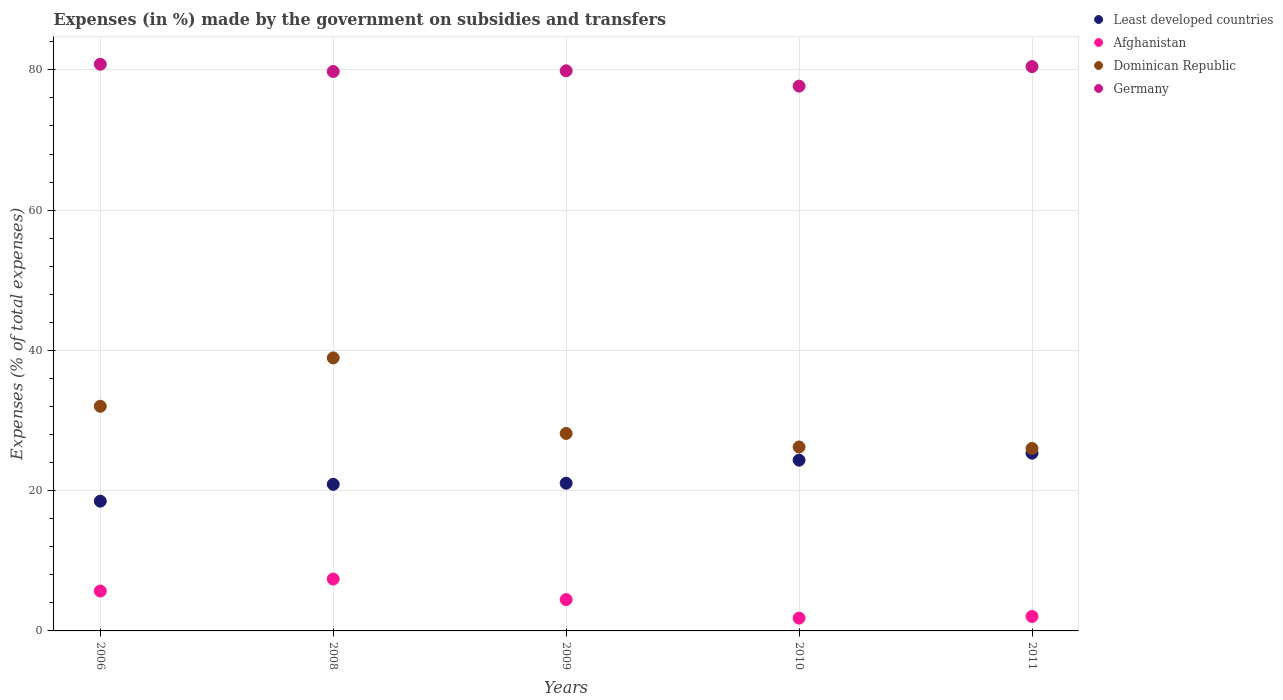How many different coloured dotlines are there?
Make the answer very short. 4. What is the percentage of expenses made by the government on subsidies and transfers in Least developed countries in 2009?
Give a very brief answer. 21.06. Across all years, what is the maximum percentage of expenses made by the government on subsidies and transfers in Dominican Republic?
Your answer should be very brief. 38.93. Across all years, what is the minimum percentage of expenses made by the government on subsidies and transfers in Afghanistan?
Keep it short and to the point. 1.82. In which year was the percentage of expenses made by the government on subsidies and transfers in Dominican Republic maximum?
Offer a terse response. 2008. In which year was the percentage of expenses made by the government on subsidies and transfers in Least developed countries minimum?
Your response must be concise. 2006. What is the total percentage of expenses made by the government on subsidies and transfers in Germany in the graph?
Your response must be concise. 398.6. What is the difference between the percentage of expenses made by the government on subsidies and transfers in Least developed countries in 2010 and that in 2011?
Offer a terse response. -1. What is the difference between the percentage of expenses made by the government on subsidies and transfers in Dominican Republic in 2006 and the percentage of expenses made by the government on subsidies and transfers in Afghanistan in 2011?
Your response must be concise. 29.97. What is the average percentage of expenses made by the government on subsidies and transfers in Afghanistan per year?
Provide a succinct answer. 4.29. In the year 2009, what is the difference between the percentage of expenses made by the government on subsidies and transfers in Germany and percentage of expenses made by the government on subsidies and transfers in Dominican Republic?
Your answer should be very brief. 51.71. What is the ratio of the percentage of expenses made by the government on subsidies and transfers in Germany in 2009 to that in 2010?
Your response must be concise. 1.03. Is the percentage of expenses made by the government on subsidies and transfers in Least developed countries in 2009 less than that in 2010?
Your answer should be compact. Yes. What is the difference between the highest and the second highest percentage of expenses made by the government on subsidies and transfers in Least developed countries?
Ensure brevity in your answer.  1. What is the difference between the highest and the lowest percentage of expenses made by the government on subsidies and transfers in Least developed countries?
Make the answer very short. 6.84. In how many years, is the percentage of expenses made by the government on subsidies and transfers in Germany greater than the average percentage of expenses made by the government on subsidies and transfers in Germany taken over all years?
Offer a very short reply. 4. Is it the case that in every year, the sum of the percentage of expenses made by the government on subsidies and transfers in Germany and percentage of expenses made by the government on subsidies and transfers in Least developed countries  is greater than the sum of percentage of expenses made by the government on subsidies and transfers in Dominican Republic and percentage of expenses made by the government on subsidies and transfers in Afghanistan?
Offer a terse response. Yes. Does the percentage of expenses made by the government on subsidies and transfers in Afghanistan monotonically increase over the years?
Your answer should be compact. No. Is the percentage of expenses made by the government on subsidies and transfers in Dominican Republic strictly greater than the percentage of expenses made by the government on subsidies and transfers in Least developed countries over the years?
Provide a short and direct response. Yes. Is the percentage of expenses made by the government on subsidies and transfers in Germany strictly less than the percentage of expenses made by the government on subsidies and transfers in Dominican Republic over the years?
Your answer should be compact. No. What is the difference between two consecutive major ticks on the Y-axis?
Your answer should be compact. 20. Does the graph contain any zero values?
Give a very brief answer. No. Does the graph contain grids?
Keep it short and to the point. Yes. How are the legend labels stacked?
Give a very brief answer. Vertical. What is the title of the graph?
Offer a very short reply. Expenses (in %) made by the government on subsidies and transfers. Does "Congo (Democratic)" appear as one of the legend labels in the graph?
Your answer should be compact. No. What is the label or title of the Y-axis?
Provide a short and direct response. Expenses (% of total expenses). What is the Expenses (% of total expenses) of Least developed countries in 2006?
Ensure brevity in your answer.  18.5. What is the Expenses (% of total expenses) in Afghanistan in 2006?
Provide a short and direct response. 5.69. What is the Expenses (% of total expenses) of Dominican Republic in 2006?
Give a very brief answer. 32.03. What is the Expenses (% of total expenses) of Germany in 2006?
Provide a short and direct response. 80.8. What is the Expenses (% of total expenses) in Least developed countries in 2008?
Offer a terse response. 20.9. What is the Expenses (% of total expenses) of Afghanistan in 2008?
Make the answer very short. 7.4. What is the Expenses (% of total expenses) in Dominican Republic in 2008?
Keep it short and to the point. 38.93. What is the Expenses (% of total expenses) in Germany in 2008?
Your answer should be compact. 79.77. What is the Expenses (% of total expenses) in Least developed countries in 2009?
Provide a short and direct response. 21.06. What is the Expenses (% of total expenses) of Afghanistan in 2009?
Provide a short and direct response. 4.47. What is the Expenses (% of total expenses) of Dominican Republic in 2009?
Offer a very short reply. 28.16. What is the Expenses (% of total expenses) of Germany in 2009?
Keep it short and to the point. 79.87. What is the Expenses (% of total expenses) of Least developed countries in 2010?
Offer a terse response. 24.35. What is the Expenses (% of total expenses) of Afghanistan in 2010?
Your answer should be compact. 1.82. What is the Expenses (% of total expenses) in Dominican Republic in 2010?
Provide a succinct answer. 26.23. What is the Expenses (% of total expenses) of Germany in 2010?
Your answer should be compact. 77.69. What is the Expenses (% of total expenses) in Least developed countries in 2011?
Keep it short and to the point. 25.34. What is the Expenses (% of total expenses) in Afghanistan in 2011?
Your response must be concise. 2.06. What is the Expenses (% of total expenses) of Dominican Republic in 2011?
Make the answer very short. 26.02. What is the Expenses (% of total expenses) of Germany in 2011?
Offer a terse response. 80.47. Across all years, what is the maximum Expenses (% of total expenses) in Least developed countries?
Offer a terse response. 25.34. Across all years, what is the maximum Expenses (% of total expenses) of Afghanistan?
Provide a succinct answer. 7.4. Across all years, what is the maximum Expenses (% of total expenses) in Dominican Republic?
Ensure brevity in your answer.  38.93. Across all years, what is the maximum Expenses (% of total expenses) of Germany?
Make the answer very short. 80.8. Across all years, what is the minimum Expenses (% of total expenses) in Least developed countries?
Provide a short and direct response. 18.5. Across all years, what is the minimum Expenses (% of total expenses) of Afghanistan?
Your answer should be very brief. 1.82. Across all years, what is the minimum Expenses (% of total expenses) of Dominican Republic?
Ensure brevity in your answer.  26.02. Across all years, what is the minimum Expenses (% of total expenses) of Germany?
Your response must be concise. 77.69. What is the total Expenses (% of total expenses) of Least developed countries in the graph?
Give a very brief answer. 110.16. What is the total Expenses (% of total expenses) in Afghanistan in the graph?
Offer a very short reply. 21.44. What is the total Expenses (% of total expenses) of Dominican Republic in the graph?
Your answer should be compact. 151.37. What is the total Expenses (% of total expenses) of Germany in the graph?
Offer a very short reply. 398.6. What is the difference between the Expenses (% of total expenses) in Least developed countries in 2006 and that in 2008?
Your response must be concise. -2.4. What is the difference between the Expenses (% of total expenses) of Afghanistan in 2006 and that in 2008?
Ensure brevity in your answer.  -1.71. What is the difference between the Expenses (% of total expenses) in Dominican Republic in 2006 and that in 2008?
Offer a terse response. -6.9. What is the difference between the Expenses (% of total expenses) of Germany in 2006 and that in 2008?
Offer a very short reply. 1.03. What is the difference between the Expenses (% of total expenses) of Least developed countries in 2006 and that in 2009?
Offer a very short reply. -2.56. What is the difference between the Expenses (% of total expenses) of Afghanistan in 2006 and that in 2009?
Make the answer very short. 1.22. What is the difference between the Expenses (% of total expenses) of Dominican Republic in 2006 and that in 2009?
Your answer should be compact. 3.88. What is the difference between the Expenses (% of total expenses) of Germany in 2006 and that in 2009?
Ensure brevity in your answer.  0.93. What is the difference between the Expenses (% of total expenses) in Least developed countries in 2006 and that in 2010?
Provide a short and direct response. -5.85. What is the difference between the Expenses (% of total expenses) of Afghanistan in 2006 and that in 2010?
Offer a very short reply. 3.86. What is the difference between the Expenses (% of total expenses) of Dominican Republic in 2006 and that in 2010?
Your answer should be very brief. 5.8. What is the difference between the Expenses (% of total expenses) in Germany in 2006 and that in 2010?
Provide a short and direct response. 3.11. What is the difference between the Expenses (% of total expenses) of Least developed countries in 2006 and that in 2011?
Give a very brief answer. -6.84. What is the difference between the Expenses (% of total expenses) in Afghanistan in 2006 and that in 2011?
Keep it short and to the point. 3.63. What is the difference between the Expenses (% of total expenses) of Dominican Republic in 2006 and that in 2011?
Your answer should be very brief. 6.02. What is the difference between the Expenses (% of total expenses) in Germany in 2006 and that in 2011?
Your response must be concise. 0.33. What is the difference between the Expenses (% of total expenses) of Least developed countries in 2008 and that in 2009?
Keep it short and to the point. -0.16. What is the difference between the Expenses (% of total expenses) in Afghanistan in 2008 and that in 2009?
Keep it short and to the point. 2.93. What is the difference between the Expenses (% of total expenses) of Dominican Republic in 2008 and that in 2009?
Provide a short and direct response. 10.78. What is the difference between the Expenses (% of total expenses) of Germany in 2008 and that in 2009?
Your answer should be compact. -0.1. What is the difference between the Expenses (% of total expenses) in Least developed countries in 2008 and that in 2010?
Your response must be concise. -3.45. What is the difference between the Expenses (% of total expenses) in Afghanistan in 2008 and that in 2010?
Ensure brevity in your answer.  5.57. What is the difference between the Expenses (% of total expenses) in Dominican Republic in 2008 and that in 2010?
Your answer should be very brief. 12.7. What is the difference between the Expenses (% of total expenses) in Germany in 2008 and that in 2010?
Your response must be concise. 2.08. What is the difference between the Expenses (% of total expenses) in Least developed countries in 2008 and that in 2011?
Provide a succinct answer. -4.44. What is the difference between the Expenses (% of total expenses) of Afghanistan in 2008 and that in 2011?
Ensure brevity in your answer.  5.34. What is the difference between the Expenses (% of total expenses) of Dominican Republic in 2008 and that in 2011?
Make the answer very short. 12.92. What is the difference between the Expenses (% of total expenses) of Germany in 2008 and that in 2011?
Make the answer very short. -0.7. What is the difference between the Expenses (% of total expenses) in Least developed countries in 2009 and that in 2010?
Ensure brevity in your answer.  -3.29. What is the difference between the Expenses (% of total expenses) in Afghanistan in 2009 and that in 2010?
Your response must be concise. 2.64. What is the difference between the Expenses (% of total expenses) in Dominican Republic in 2009 and that in 2010?
Provide a succinct answer. 1.93. What is the difference between the Expenses (% of total expenses) in Germany in 2009 and that in 2010?
Keep it short and to the point. 2.18. What is the difference between the Expenses (% of total expenses) in Least developed countries in 2009 and that in 2011?
Ensure brevity in your answer.  -4.28. What is the difference between the Expenses (% of total expenses) of Afghanistan in 2009 and that in 2011?
Give a very brief answer. 2.4. What is the difference between the Expenses (% of total expenses) in Dominican Republic in 2009 and that in 2011?
Offer a very short reply. 2.14. What is the difference between the Expenses (% of total expenses) of Germany in 2009 and that in 2011?
Provide a succinct answer. -0.6. What is the difference between the Expenses (% of total expenses) in Least developed countries in 2010 and that in 2011?
Ensure brevity in your answer.  -1. What is the difference between the Expenses (% of total expenses) of Afghanistan in 2010 and that in 2011?
Provide a short and direct response. -0.24. What is the difference between the Expenses (% of total expenses) of Dominican Republic in 2010 and that in 2011?
Make the answer very short. 0.21. What is the difference between the Expenses (% of total expenses) of Germany in 2010 and that in 2011?
Provide a short and direct response. -2.78. What is the difference between the Expenses (% of total expenses) of Least developed countries in 2006 and the Expenses (% of total expenses) of Afghanistan in 2008?
Make the answer very short. 11.1. What is the difference between the Expenses (% of total expenses) in Least developed countries in 2006 and the Expenses (% of total expenses) in Dominican Republic in 2008?
Provide a succinct answer. -20.43. What is the difference between the Expenses (% of total expenses) in Least developed countries in 2006 and the Expenses (% of total expenses) in Germany in 2008?
Your answer should be very brief. -61.27. What is the difference between the Expenses (% of total expenses) in Afghanistan in 2006 and the Expenses (% of total expenses) in Dominican Republic in 2008?
Provide a short and direct response. -33.25. What is the difference between the Expenses (% of total expenses) in Afghanistan in 2006 and the Expenses (% of total expenses) in Germany in 2008?
Provide a succinct answer. -74.08. What is the difference between the Expenses (% of total expenses) in Dominican Republic in 2006 and the Expenses (% of total expenses) in Germany in 2008?
Keep it short and to the point. -47.74. What is the difference between the Expenses (% of total expenses) in Least developed countries in 2006 and the Expenses (% of total expenses) in Afghanistan in 2009?
Your answer should be compact. 14.04. What is the difference between the Expenses (% of total expenses) of Least developed countries in 2006 and the Expenses (% of total expenses) of Dominican Republic in 2009?
Offer a very short reply. -9.65. What is the difference between the Expenses (% of total expenses) of Least developed countries in 2006 and the Expenses (% of total expenses) of Germany in 2009?
Give a very brief answer. -61.37. What is the difference between the Expenses (% of total expenses) in Afghanistan in 2006 and the Expenses (% of total expenses) in Dominican Republic in 2009?
Make the answer very short. -22.47. What is the difference between the Expenses (% of total expenses) of Afghanistan in 2006 and the Expenses (% of total expenses) of Germany in 2009?
Your response must be concise. -74.18. What is the difference between the Expenses (% of total expenses) in Dominican Republic in 2006 and the Expenses (% of total expenses) in Germany in 2009?
Ensure brevity in your answer.  -47.84. What is the difference between the Expenses (% of total expenses) in Least developed countries in 2006 and the Expenses (% of total expenses) in Afghanistan in 2010?
Offer a very short reply. 16.68. What is the difference between the Expenses (% of total expenses) of Least developed countries in 2006 and the Expenses (% of total expenses) of Dominican Republic in 2010?
Give a very brief answer. -7.73. What is the difference between the Expenses (% of total expenses) in Least developed countries in 2006 and the Expenses (% of total expenses) in Germany in 2010?
Give a very brief answer. -59.18. What is the difference between the Expenses (% of total expenses) in Afghanistan in 2006 and the Expenses (% of total expenses) in Dominican Republic in 2010?
Provide a short and direct response. -20.54. What is the difference between the Expenses (% of total expenses) in Afghanistan in 2006 and the Expenses (% of total expenses) in Germany in 2010?
Provide a succinct answer. -72. What is the difference between the Expenses (% of total expenses) of Dominican Republic in 2006 and the Expenses (% of total expenses) of Germany in 2010?
Give a very brief answer. -45.66. What is the difference between the Expenses (% of total expenses) of Least developed countries in 2006 and the Expenses (% of total expenses) of Afghanistan in 2011?
Give a very brief answer. 16.44. What is the difference between the Expenses (% of total expenses) of Least developed countries in 2006 and the Expenses (% of total expenses) of Dominican Republic in 2011?
Your answer should be very brief. -7.51. What is the difference between the Expenses (% of total expenses) in Least developed countries in 2006 and the Expenses (% of total expenses) in Germany in 2011?
Give a very brief answer. -61.97. What is the difference between the Expenses (% of total expenses) of Afghanistan in 2006 and the Expenses (% of total expenses) of Dominican Republic in 2011?
Provide a short and direct response. -20.33. What is the difference between the Expenses (% of total expenses) in Afghanistan in 2006 and the Expenses (% of total expenses) in Germany in 2011?
Provide a short and direct response. -74.78. What is the difference between the Expenses (% of total expenses) of Dominican Republic in 2006 and the Expenses (% of total expenses) of Germany in 2011?
Provide a short and direct response. -48.44. What is the difference between the Expenses (% of total expenses) in Least developed countries in 2008 and the Expenses (% of total expenses) in Afghanistan in 2009?
Your answer should be compact. 16.44. What is the difference between the Expenses (% of total expenses) in Least developed countries in 2008 and the Expenses (% of total expenses) in Dominican Republic in 2009?
Ensure brevity in your answer.  -7.25. What is the difference between the Expenses (% of total expenses) in Least developed countries in 2008 and the Expenses (% of total expenses) in Germany in 2009?
Your answer should be compact. -58.97. What is the difference between the Expenses (% of total expenses) of Afghanistan in 2008 and the Expenses (% of total expenses) of Dominican Republic in 2009?
Provide a succinct answer. -20.76. What is the difference between the Expenses (% of total expenses) of Afghanistan in 2008 and the Expenses (% of total expenses) of Germany in 2009?
Provide a short and direct response. -72.47. What is the difference between the Expenses (% of total expenses) of Dominican Republic in 2008 and the Expenses (% of total expenses) of Germany in 2009?
Make the answer very short. -40.94. What is the difference between the Expenses (% of total expenses) of Least developed countries in 2008 and the Expenses (% of total expenses) of Afghanistan in 2010?
Offer a very short reply. 19.08. What is the difference between the Expenses (% of total expenses) in Least developed countries in 2008 and the Expenses (% of total expenses) in Dominican Republic in 2010?
Provide a succinct answer. -5.33. What is the difference between the Expenses (% of total expenses) of Least developed countries in 2008 and the Expenses (% of total expenses) of Germany in 2010?
Your answer should be compact. -56.78. What is the difference between the Expenses (% of total expenses) of Afghanistan in 2008 and the Expenses (% of total expenses) of Dominican Republic in 2010?
Your response must be concise. -18.83. What is the difference between the Expenses (% of total expenses) in Afghanistan in 2008 and the Expenses (% of total expenses) in Germany in 2010?
Your answer should be very brief. -70.29. What is the difference between the Expenses (% of total expenses) in Dominican Republic in 2008 and the Expenses (% of total expenses) in Germany in 2010?
Your answer should be compact. -38.75. What is the difference between the Expenses (% of total expenses) of Least developed countries in 2008 and the Expenses (% of total expenses) of Afghanistan in 2011?
Provide a short and direct response. 18.84. What is the difference between the Expenses (% of total expenses) in Least developed countries in 2008 and the Expenses (% of total expenses) in Dominican Republic in 2011?
Your answer should be compact. -5.11. What is the difference between the Expenses (% of total expenses) in Least developed countries in 2008 and the Expenses (% of total expenses) in Germany in 2011?
Provide a succinct answer. -59.57. What is the difference between the Expenses (% of total expenses) in Afghanistan in 2008 and the Expenses (% of total expenses) in Dominican Republic in 2011?
Make the answer very short. -18.62. What is the difference between the Expenses (% of total expenses) in Afghanistan in 2008 and the Expenses (% of total expenses) in Germany in 2011?
Keep it short and to the point. -73.07. What is the difference between the Expenses (% of total expenses) in Dominican Republic in 2008 and the Expenses (% of total expenses) in Germany in 2011?
Give a very brief answer. -41.54. What is the difference between the Expenses (% of total expenses) in Least developed countries in 2009 and the Expenses (% of total expenses) in Afghanistan in 2010?
Offer a very short reply. 19.24. What is the difference between the Expenses (% of total expenses) in Least developed countries in 2009 and the Expenses (% of total expenses) in Dominican Republic in 2010?
Keep it short and to the point. -5.17. What is the difference between the Expenses (% of total expenses) of Least developed countries in 2009 and the Expenses (% of total expenses) of Germany in 2010?
Offer a very short reply. -56.62. What is the difference between the Expenses (% of total expenses) of Afghanistan in 2009 and the Expenses (% of total expenses) of Dominican Republic in 2010?
Your response must be concise. -21.76. What is the difference between the Expenses (% of total expenses) of Afghanistan in 2009 and the Expenses (% of total expenses) of Germany in 2010?
Offer a terse response. -73.22. What is the difference between the Expenses (% of total expenses) of Dominican Republic in 2009 and the Expenses (% of total expenses) of Germany in 2010?
Offer a very short reply. -49.53. What is the difference between the Expenses (% of total expenses) in Least developed countries in 2009 and the Expenses (% of total expenses) in Afghanistan in 2011?
Ensure brevity in your answer.  19. What is the difference between the Expenses (% of total expenses) in Least developed countries in 2009 and the Expenses (% of total expenses) in Dominican Republic in 2011?
Offer a very short reply. -4.95. What is the difference between the Expenses (% of total expenses) in Least developed countries in 2009 and the Expenses (% of total expenses) in Germany in 2011?
Provide a short and direct response. -59.41. What is the difference between the Expenses (% of total expenses) in Afghanistan in 2009 and the Expenses (% of total expenses) in Dominican Republic in 2011?
Make the answer very short. -21.55. What is the difference between the Expenses (% of total expenses) of Afghanistan in 2009 and the Expenses (% of total expenses) of Germany in 2011?
Your answer should be very brief. -76. What is the difference between the Expenses (% of total expenses) of Dominican Republic in 2009 and the Expenses (% of total expenses) of Germany in 2011?
Your response must be concise. -52.31. What is the difference between the Expenses (% of total expenses) in Least developed countries in 2010 and the Expenses (% of total expenses) in Afghanistan in 2011?
Offer a very short reply. 22.29. What is the difference between the Expenses (% of total expenses) in Least developed countries in 2010 and the Expenses (% of total expenses) in Dominican Republic in 2011?
Keep it short and to the point. -1.67. What is the difference between the Expenses (% of total expenses) of Least developed countries in 2010 and the Expenses (% of total expenses) of Germany in 2011?
Your response must be concise. -56.12. What is the difference between the Expenses (% of total expenses) of Afghanistan in 2010 and the Expenses (% of total expenses) of Dominican Republic in 2011?
Keep it short and to the point. -24.19. What is the difference between the Expenses (% of total expenses) of Afghanistan in 2010 and the Expenses (% of total expenses) of Germany in 2011?
Offer a terse response. -78.65. What is the difference between the Expenses (% of total expenses) of Dominican Republic in 2010 and the Expenses (% of total expenses) of Germany in 2011?
Your answer should be compact. -54.24. What is the average Expenses (% of total expenses) in Least developed countries per year?
Give a very brief answer. 22.03. What is the average Expenses (% of total expenses) in Afghanistan per year?
Offer a very short reply. 4.29. What is the average Expenses (% of total expenses) of Dominican Republic per year?
Make the answer very short. 30.27. What is the average Expenses (% of total expenses) in Germany per year?
Make the answer very short. 79.72. In the year 2006, what is the difference between the Expenses (% of total expenses) in Least developed countries and Expenses (% of total expenses) in Afghanistan?
Provide a short and direct response. 12.81. In the year 2006, what is the difference between the Expenses (% of total expenses) of Least developed countries and Expenses (% of total expenses) of Dominican Republic?
Give a very brief answer. -13.53. In the year 2006, what is the difference between the Expenses (% of total expenses) in Least developed countries and Expenses (% of total expenses) in Germany?
Provide a succinct answer. -62.3. In the year 2006, what is the difference between the Expenses (% of total expenses) in Afghanistan and Expenses (% of total expenses) in Dominican Republic?
Your answer should be very brief. -26.34. In the year 2006, what is the difference between the Expenses (% of total expenses) of Afghanistan and Expenses (% of total expenses) of Germany?
Your response must be concise. -75.11. In the year 2006, what is the difference between the Expenses (% of total expenses) in Dominican Republic and Expenses (% of total expenses) in Germany?
Keep it short and to the point. -48.77. In the year 2008, what is the difference between the Expenses (% of total expenses) in Least developed countries and Expenses (% of total expenses) in Afghanistan?
Your response must be concise. 13.5. In the year 2008, what is the difference between the Expenses (% of total expenses) in Least developed countries and Expenses (% of total expenses) in Dominican Republic?
Provide a succinct answer. -18.03. In the year 2008, what is the difference between the Expenses (% of total expenses) in Least developed countries and Expenses (% of total expenses) in Germany?
Give a very brief answer. -58.87. In the year 2008, what is the difference between the Expenses (% of total expenses) in Afghanistan and Expenses (% of total expenses) in Dominican Republic?
Provide a short and direct response. -31.54. In the year 2008, what is the difference between the Expenses (% of total expenses) of Afghanistan and Expenses (% of total expenses) of Germany?
Offer a terse response. -72.37. In the year 2008, what is the difference between the Expenses (% of total expenses) of Dominican Republic and Expenses (% of total expenses) of Germany?
Your answer should be compact. -40.84. In the year 2009, what is the difference between the Expenses (% of total expenses) in Least developed countries and Expenses (% of total expenses) in Afghanistan?
Give a very brief answer. 16.6. In the year 2009, what is the difference between the Expenses (% of total expenses) of Least developed countries and Expenses (% of total expenses) of Dominican Republic?
Provide a succinct answer. -7.09. In the year 2009, what is the difference between the Expenses (% of total expenses) in Least developed countries and Expenses (% of total expenses) in Germany?
Your answer should be compact. -58.81. In the year 2009, what is the difference between the Expenses (% of total expenses) of Afghanistan and Expenses (% of total expenses) of Dominican Republic?
Your answer should be compact. -23.69. In the year 2009, what is the difference between the Expenses (% of total expenses) in Afghanistan and Expenses (% of total expenses) in Germany?
Provide a short and direct response. -75.4. In the year 2009, what is the difference between the Expenses (% of total expenses) of Dominican Republic and Expenses (% of total expenses) of Germany?
Keep it short and to the point. -51.71. In the year 2010, what is the difference between the Expenses (% of total expenses) in Least developed countries and Expenses (% of total expenses) in Afghanistan?
Your response must be concise. 22.52. In the year 2010, what is the difference between the Expenses (% of total expenses) in Least developed countries and Expenses (% of total expenses) in Dominican Republic?
Your answer should be very brief. -1.88. In the year 2010, what is the difference between the Expenses (% of total expenses) in Least developed countries and Expenses (% of total expenses) in Germany?
Give a very brief answer. -53.34. In the year 2010, what is the difference between the Expenses (% of total expenses) of Afghanistan and Expenses (% of total expenses) of Dominican Republic?
Your answer should be very brief. -24.4. In the year 2010, what is the difference between the Expenses (% of total expenses) of Afghanistan and Expenses (% of total expenses) of Germany?
Provide a short and direct response. -75.86. In the year 2010, what is the difference between the Expenses (% of total expenses) of Dominican Republic and Expenses (% of total expenses) of Germany?
Give a very brief answer. -51.46. In the year 2011, what is the difference between the Expenses (% of total expenses) in Least developed countries and Expenses (% of total expenses) in Afghanistan?
Offer a very short reply. 23.28. In the year 2011, what is the difference between the Expenses (% of total expenses) in Least developed countries and Expenses (% of total expenses) in Dominican Republic?
Make the answer very short. -0.67. In the year 2011, what is the difference between the Expenses (% of total expenses) of Least developed countries and Expenses (% of total expenses) of Germany?
Offer a terse response. -55.13. In the year 2011, what is the difference between the Expenses (% of total expenses) in Afghanistan and Expenses (% of total expenses) in Dominican Republic?
Provide a succinct answer. -23.95. In the year 2011, what is the difference between the Expenses (% of total expenses) of Afghanistan and Expenses (% of total expenses) of Germany?
Provide a short and direct response. -78.41. In the year 2011, what is the difference between the Expenses (% of total expenses) of Dominican Republic and Expenses (% of total expenses) of Germany?
Ensure brevity in your answer.  -54.45. What is the ratio of the Expenses (% of total expenses) of Least developed countries in 2006 to that in 2008?
Give a very brief answer. 0.89. What is the ratio of the Expenses (% of total expenses) in Afghanistan in 2006 to that in 2008?
Your response must be concise. 0.77. What is the ratio of the Expenses (% of total expenses) in Dominican Republic in 2006 to that in 2008?
Offer a terse response. 0.82. What is the ratio of the Expenses (% of total expenses) of Germany in 2006 to that in 2008?
Give a very brief answer. 1.01. What is the ratio of the Expenses (% of total expenses) in Least developed countries in 2006 to that in 2009?
Provide a succinct answer. 0.88. What is the ratio of the Expenses (% of total expenses) in Afghanistan in 2006 to that in 2009?
Provide a succinct answer. 1.27. What is the ratio of the Expenses (% of total expenses) of Dominican Republic in 2006 to that in 2009?
Give a very brief answer. 1.14. What is the ratio of the Expenses (% of total expenses) in Germany in 2006 to that in 2009?
Keep it short and to the point. 1.01. What is the ratio of the Expenses (% of total expenses) of Least developed countries in 2006 to that in 2010?
Give a very brief answer. 0.76. What is the ratio of the Expenses (% of total expenses) of Afghanistan in 2006 to that in 2010?
Keep it short and to the point. 3.12. What is the ratio of the Expenses (% of total expenses) of Dominican Republic in 2006 to that in 2010?
Keep it short and to the point. 1.22. What is the ratio of the Expenses (% of total expenses) in Germany in 2006 to that in 2010?
Your response must be concise. 1.04. What is the ratio of the Expenses (% of total expenses) in Least developed countries in 2006 to that in 2011?
Ensure brevity in your answer.  0.73. What is the ratio of the Expenses (% of total expenses) of Afghanistan in 2006 to that in 2011?
Give a very brief answer. 2.76. What is the ratio of the Expenses (% of total expenses) in Dominican Republic in 2006 to that in 2011?
Provide a succinct answer. 1.23. What is the ratio of the Expenses (% of total expenses) in Least developed countries in 2008 to that in 2009?
Ensure brevity in your answer.  0.99. What is the ratio of the Expenses (% of total expenses) in Afghanistan in 2008 to that in 2009?
Offer a terse response. 1.66. What is the ratio of the Expenses (% of total expenses) in Dominican Republic in 2008 to that in 2009?
Give a very brief answer. 1.38. What is the ratio of the Expenses (% of total expenses) in Germany in 2008 to that in 2009?
Provide a succinct answer. 1. What is the ratio of the Expenses (% of total expenses) in Least developed countries in 2008 to that in 2010?
Make the answer very short. 0.86. What is the ratio of the Expenses (% of total expenses) of Afghanistan in 2008 to that in 2010?
Offer a very short reply. 4.05. What is the ratio of the Expenses (% of total expenses) in Dominican Republic in 2008 to that in 2010?
Your response must be concise. 1.48. What is the ratio of the Expenses (% of total expenses) in Germany in 2008 to that in 2010?
Make the answer very short. 1.03. What is the ratio of the Expenses (% of total expenses) of Least developed countries in 2008 to that in 2011?
Give a very brief answer. 0.82. What is the ratio of the Expenses (% of total expenses) of Afghanistan in 2008 to that in 2011?
Offer a very short reply. 3.59. What is the ratio of the Expenses (% of total expenses) in Dominican Republic in 2008 to that in 2011?
Make the answer very short. 1.5. What is the ratio of the Expenses (% of total expenses) of Least developed countries in 2009 to that in 2010?
Offer a very short reply. 0.86. What is the ratio of the Expenses (% of total expenses) of Afghanistan in 2009 to that in 2010?
Your answer should be compact. 2.45. What is the ratio of the Expenses (% of total expenses) in Dominican Republic in 2009 to that in 2010?
Your response must be concise. 1.07. What is the ratio of the Expenses (% of total expenses) in Germany in 2009 to that in 2010?
Your response must be concise. 1.03. What is the ratio of the Expenses (% of total expenses) in Least developed countries in 2009 to that in 2011?
Provide a short and direct response. 0.83. What is the ratio of the Expenses (% of total expenses) of Afghanistan in 2009 to that in 2011?
Your response must be concise. 2.17. What is the ratio of the Expenses (% of total expenses) of Dominican Republic in 2009 to that in 2011?
Offer a very short reply. 1.08. What is the ratio of the Expenses (% of total expenses) in Least developed countries in 2010 to that in 2011?
Offer a terse response. 0.96. What is the ratio of the Expenses (% of total expenses) of Afghanistan in 2010 to that in 2011?
Provide a succinct answer. 0.89. What is the ratio of the Expenses (% of total expenses) of Dominican Republic in 2010 to that in 2011?
Keep it short and to the point. 1.01. What is the ratio of the Expenses (% of total expenses) of Germany in 2010 to that in 2011?
Offer a very short reply. 0.97. What is the difference between the highest and the second highest Expenses (% of total expenses) of Afghanistan?
Your response must be concise. 1.71. What is the difference between the highest and the second highest Expenses (% of total expenses) of Dominican Republic?
Provide a succinct answer. 6.9. What is the difference between the highest and the second highest Expenses (% of total expenses) of Germany?
Provide a succinct answer. 0.33. What is the difference between the highest and the lowest Expenses (% of total expenses) in Least developed countries?
Offer a very short reply. 6.84. What is the difference between the highest and the lowest Expenses (% of total expenses) in Afghanistan?
Provide a short and direct response. 5.57. What is the difference between the highest and the lowest Expenses (% of total expenses) of Dominican Republic?
Provide a short and direct response. 12.92. What is the difference between the highest and the lowest Expenses (% of total expenses) of Germany?
Your answer should be very brief. 3.11. 